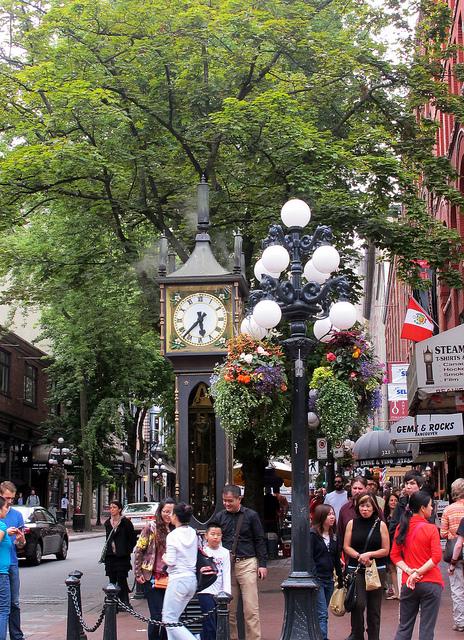Are the people wearing summer clothes?
Quick response, please. No. Can you see people wearing hard hats?
Short answer required. No. Is it raining?
Be succinct. No. Was this picture taken from outside the window?
Short answer required. No. Is this in London?
Short answer required. Yes. What holiday are they celebrating?
Answer briefly. Christmas. How are most people getting around?
Be succinct. Walking. Is this an African celebration?
Give a very brief answer. No. What time is it?
Short answer required. 5:36. 